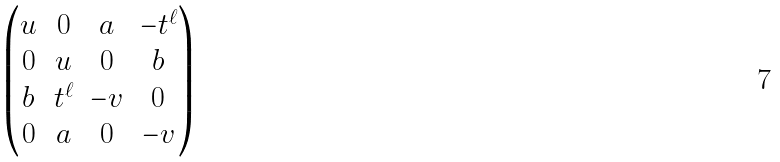Convert formula to latex. <formula><loc_0><loc_0><loc_500><loc_500>\begin{pmatrix} u & 0 & a & - t ^ { \ell } \\ 0 & u & 0 & b \\ b & t ^ { \ell } & - v & 0 \\ 0 & a & 0 & - v \end{pmatrix}</formula> 